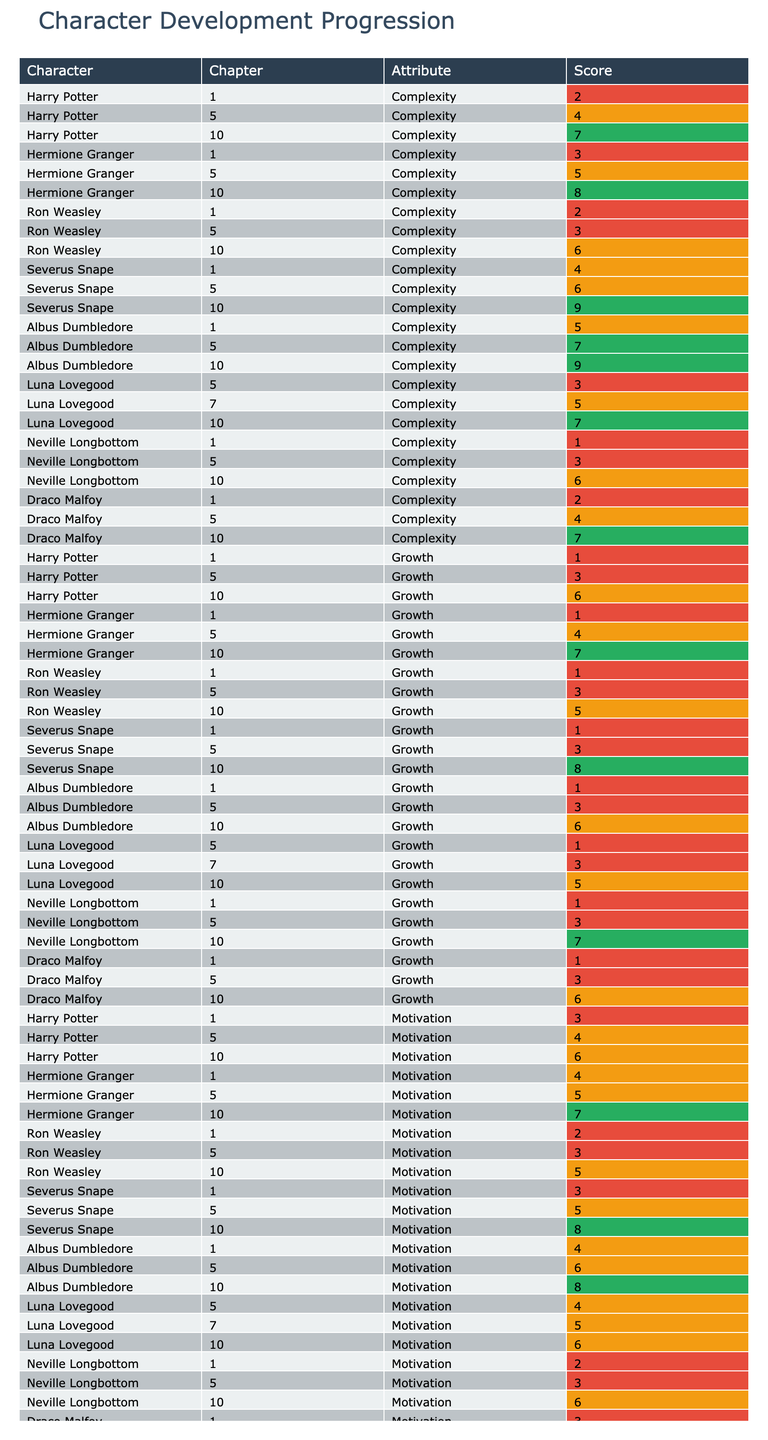What is the highest complexity score for Harry Potter in any chapter? The complexity scores for Harry Potter across the chapters are 2 (Chapter 1), 4 (Chapter 5), and 7 (Chapter 10). The highest score is 7 in Chapter 10.
Answer: 7 Which character experienced the most growth by Chapter 10? The growth scores for the characters in Chapter 10 are: Harry Potter (6), Hermione Granger (7), Ron Weasley (5), Severus Snape (8), Albus Dumbledore (6), Luna Lovegood (5), Neville Longbottom (7), and Draco Malfoy (6). Hermione Granger and Severus Snape both scored 8, indicating the highest growth.
Answer: Hermione Granger and Severus Snape What is the average motivation score for the characters in Chapter 5? The motivation scores for Chapter 5 are: Harry Potter (4), Hermione Granger (5), Ron Weasley (3), Severus Snape (5), Albus Dumbledore (6), Luna Lovegood (4), Neville Longbottom (3), and Draco Malfoy (4). Sum: 4 + 5 + 3 + 5 + 6 + 4 + 3 + 4 = 34. There are 8 scores, so the average is 34/8 = 4.25.
Answer: 4.25 Did Neville Longbottom demonstrate any growth in Chapter 10 compared to Chapter 5? Neville Longbottom's growth scores are 3 in Chapter 5 and 7 in Chapter 10. Since 7 is greater than 3, he did demonstrate growth.
Answer: Yes What is the difference in relationship development scores for Severus Snape between Chapters 1 and 10? Severus Snape's relationship development scores are 1 in Chapter 1 and 7 in Chapter 10. The difference is 7 - 1 = 6.
Answer: 6 Which character had the same complexity score in Chapters 1 and 5? Looking at the complexity scores, Ron Weasley has a score of 2 in Chapter 1 and 3 in Chapter 5, Draco Malfoy scores 2 in Chapter 1 and 4 in Chapter 5. However, no character maintained the same score across those chapters.
Answer: None Is the relationship development score for Luna Lovegood in Chapter 10 higher than that of Ron Weasley in the same chapter? Luna Lovegood's relationship score in Chapter 10 is 5, while Ron Weasley's is 5 as well, so they are the same.
Answer: No What can be inferred about Albus Dumbledore's complexity score from Chapter 1 to Chapter 10? Albus Dumbledore's complexity scores change from 5 in Chapter 1 to 9 in Chapter 10, indicating an increase of 4. This reflects a progression in complexity as the series develops.
Answer: Increased by 4 Which character has the lowest motivation score in Chapter 1? Analyzing Chapter 1, Harry Potter has a motivation score of 3, Hermione Granger has 4, Ron Weasley has 2, Severus Snape has 3, Albus Dumbledore has 4, Luna Lovegood is absent, Neville Longbottom is 2, and Draco Malfoy is 3. Ron Weasley and Neville Longbottom both score 2, which is the lowest.
Answer: Ron Weasley and Neville Longbottom How many characters maintained or improved their complexity score from Chapter 1 to Chapter 10? The complexity scores are: Harry Potter – 2 to 7, Hermione Granger – 3 to 8, Ron Weasley – 2 to 6, Severus Snape – 4 to 9, Albus Dumbledore – 5 to 9, Luna Lovegood (not applicable as Chapter 10 is not included), Neville Longbottom (1 to 6), Draco Malfoy – 2 to 7. All characters except Ron Weasley maintained or improved their complexity score.
Answer: 6 characters 